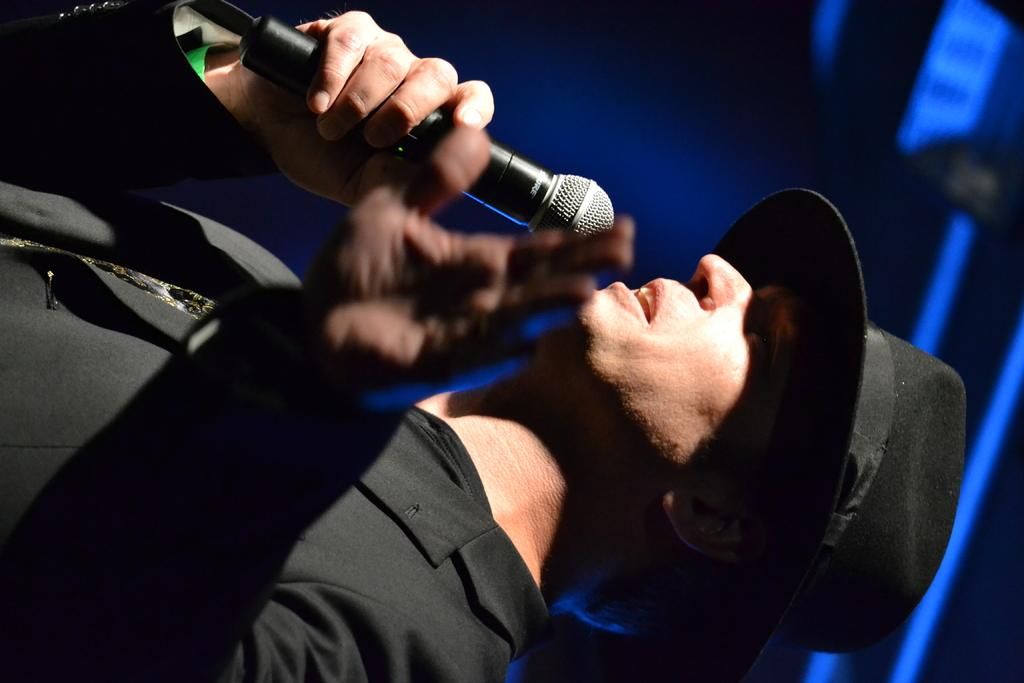Who is present in the image? There is a person in the image. What is the person wearing? The person is wearing a dress and a hat. What is the person holding in the image? The person is holding a microphone. What can be seen in the background of the image? There are lights visible in the background of the image. What type of sleet can be seen falling in the image? There is no sleet present in the image; it is an indoor setting with lights visible in the background. What color is the silver glue used to attach the hat to the person's head? There is no glue or silver mentioned in the image; the person is wearing a hat and a dress. 